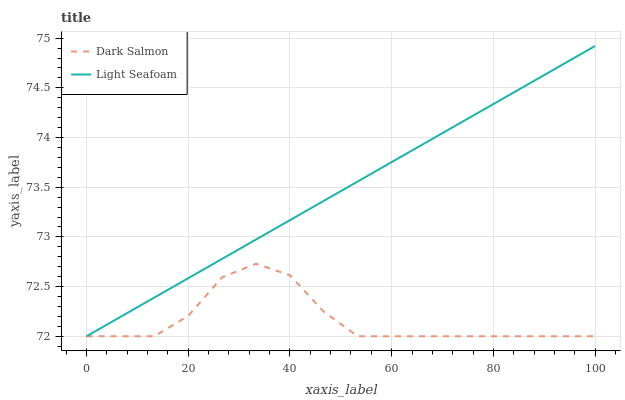Does Dark Salmon have the maximum area under the curve?
Answer yes or no. No. Is Dark Salmon the smoothest?
Answer yes or no. No. Does Dark Salmon have the highest value?
Answer yes or no. No. 